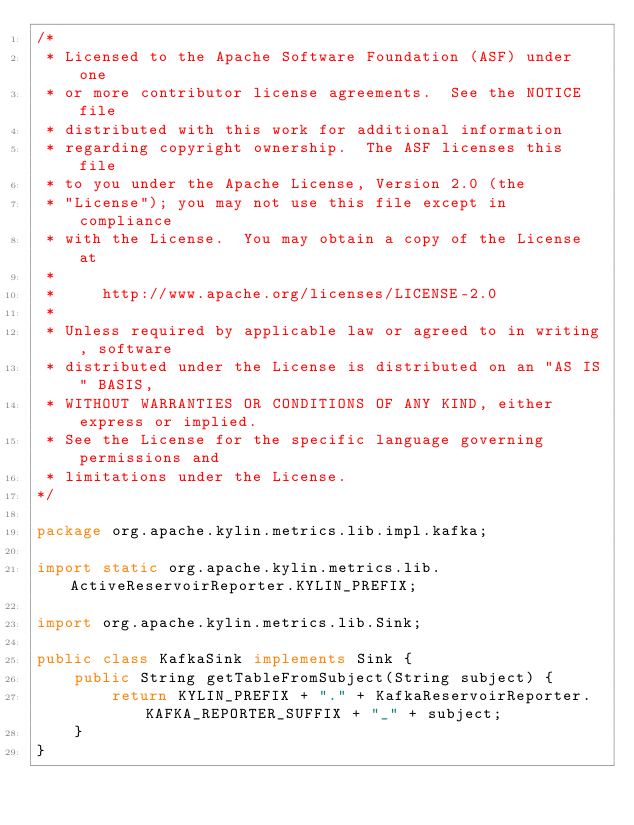<code> <loc_0><loc_0><loc_500><loc_500><_Java_>/*
 * Licensed to the Apache Software Foundation (ASF) under one
 * or more contributor license agreements.  See the NOTICE file
 * distributed with this work for additional information
 * regarding copyright ownership.  The ASF licenses this file
 * to you under the Apache License, Version 2.0 (the
 * "License"); you may not use this file except in compliance
 * with the License.  You may obtain a copy of the License at
 *
 *     http://www.apache.org/licenses/LICENSE-2.0
 *
 * Unless required by applicable law or agreed to in writing, software
 * distributed under the License is distributed on an "AS IS" BASIS,
 * WITHOUT WARRANTIES OR CONDITIONS OF ANY KIND, either express or implied.
 * See the License for the specific language governing permissions and
 * limitations under the License.
*/

package org.apache.kylin.metrics.lib.impl.kafka;

import static org.apache.kylin.metrics.lib.ActiveReservoirReporter.KYLIN_PREFIX;

import org.apache.kylin.metrics.lib.Sink;

public class KafkaSink implements Sink {
    public String getTableFromSubject(String subject) {
        return KYLIN_PREFIX + "." + KafkaReservoirReporter.KAFKA_REPORTER_SUFFIX + "_" + subject;
    }
}
</code> 